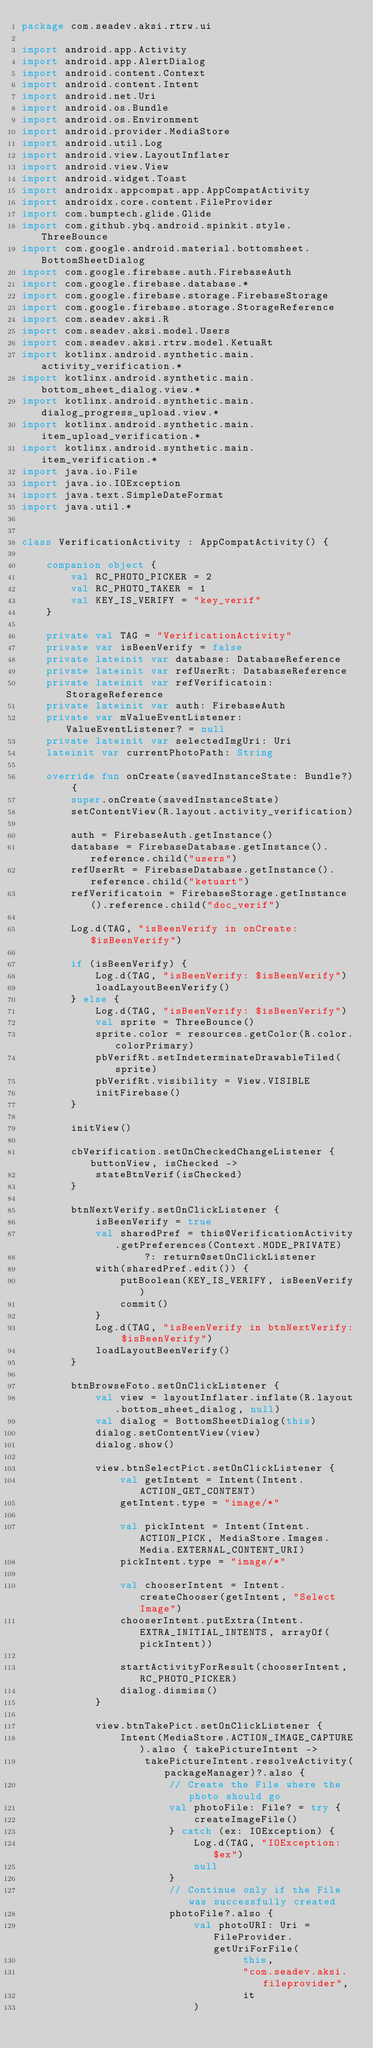<code> <loc_0><loc_0><loc_500><loc_500><_Kotlin_>package com.seadev.aksi.rtrw.ui

import android.app.Activity
import android.app.AlertDialog
import android.content.Context
import android.content.Intent
import android.net.Uri
import android.os.Bundle
import android.os.Environment
import android.provider.MediaStore
import android.util.Log
import android.view.LayoutInflater
import android.view.View
import android.widget.Toast
import androidx.appcompat.app.AppCompatActivity
import androidx.core.content.FileProvider
import com.bumptech.glide.Glide
import com.github.ybq.android.spinkit.style.ThreeBounce
import com.google.android.material.bottomsheet.BottomSheetDialog
import com.google.firebase.auth.FirebaseAuth
import com.google.firebase.database.*
import com.google.firebase.storage.FirebaseStorage
import com.google.firebase.storage.StorageReference
import com.seadev.aksi.R
import com.seadev.aksi.model.Users
import com.seadev.aksi.rtrw.model.KetuaRt
import kotlinx.android.synthetic.main.activity_verification.*
import kotlinx.android.synthetic.main.bottom_sheet_dialog.view.*
import kotlinx.android.synthetic.main.dialog_progress_upload.view.*
import kotlinx.android.synthetic.main.item_upload_verification.*
import kotlinx.android.synthetic.main.item_verification.*
import java.io.File
import java.io.IOException
import java.text.SimpleDateFormat
import java.util.*


class VerificationActivity : AppCompatActivity() {

    companion object {
        val RC_PHOTO_PICKER = 2
        val RC_PHOTO_TAKER = 1
        val KEY_IS_VERIFY = "key_verif"
    }

    private val TAG = "VerificationActivity"
    private var isBeenVerify = false
    private lateinit var database: DatabaseReference
    private lateinit var refUserRt: DatabaseReference
    private lateinit var refVerificatoin: StorageReference
    private lateinit var auth: FirebaseAuth
    private var mValueEventListener: ValueEventListener? = null
    private lateinit var selectedImgUri: Uri
    lateinit var currentPhotoPath: String

    override fun onCreate(savedInstanceState: Bundle?) {
        super.onCreate(savedInstanceState)
        setContentView(R.layout.activity_verification)

        auth = FirebaseAuth.getInstance()
        database = FirebaseDatabase.getInstance().reference.child("users")
        refUserRt = FirebaseDatabase.getInstance().reference.child("ketuart")
        refVerificatoin = FirebaseStorage.getInstance().reference.child("doc_verif")

        Log.d(TAG, "isBeenVerify in onCreate: $isBeenVerify")

        if (isBeenVerify) {
            Log.d(TAG, "isBeenVerify: $isBeenVerify")
            loadLayoutBeenVerify()
        } else {
            Log.d(TAG, "isBeenVerify: $isBeenVerify")
            val sprite = ThreeBounce()
            sprite.color = resources.getColor(R.color.colorPrimary)
            pbVerifRt.setIndeterminateDrawableTiled(sprite)
            pbVerifRt.visibility = View.VISIBLE
            initFirebase()
        }

        initView()

        cbVerification.setOnCheckedChangeListener { buttonView, isChecked ->
            stateBtnVerif(isChecked)
        }

        btnNextVerify.setOnClickListener {
            isBeenVerify = true
            val sharedPref = this@VerificationActivity.getPreferences(Context.MODE_PRIVATE)
                    ?: return@setOnClickListener
            with(sharedPref.edit()) {
                putBoolean(KEY_IS_VERIFY, isBeenVerify)
                commit()
            }
            Log.d(TAG, "isBeenVerify in btnNextVerify: $isBeenVerify")
            loadLayoutBeenVerify()
        }

        btnBrowseFoto.setOnClickListener {
            val view = layoutInflater.inflate(R.layout.bottom_sheet_dialog, null)
            val dialog = BottomSheetDialog(this)
            dialog.setContentView(view)
            dialog.show()

            view.btnSelectPict.setOnClickListener {
                val getIntent = Intent(Intent.ACTION_GET_CONTENT)
                getIntent.type = "image/*"

                val pickIntent = Intent(Intent.ACTION_PICK, MediaStore.Images.Media.EXTERNAL_CONTENT_URI)
                pickIntent.type = "image/*"

                val chooserIntent = Intent.createChooser(getIntent, "Select Image")
                chooserIntent.putExtra(Intent.EXTRA_INITIAL_INTENTS, arrayOf(pickIntent))

                startActivityForResult(chooserIntent, RC_PHOTO_PICKER)
                dialog.dismiss()
            }

            view.btnTakePict.setOnClickListener {
                Intent(MediaStore.ACTION_IMAGE_CAPTURE).also { takePictureIntent ->
                    takePictureIntent.resolveActivity(packageManager)?.also {
                        // Create the File where the photo should go
                        val photoFile: File? = try {
                            createImageFile()
                        } catch (ex: IOException) {
                            Log.d(TAG, "IOException: $ex")
                            null
                        }
                        // Continue only if the File was successfully created
                        photoFile?.also {
                            val photoURI: Uri = FileProvider.getUriForFile(
                                    this,
                                    "com.seadev.aksi.fileprovider",
                                    it
                            )</code> 